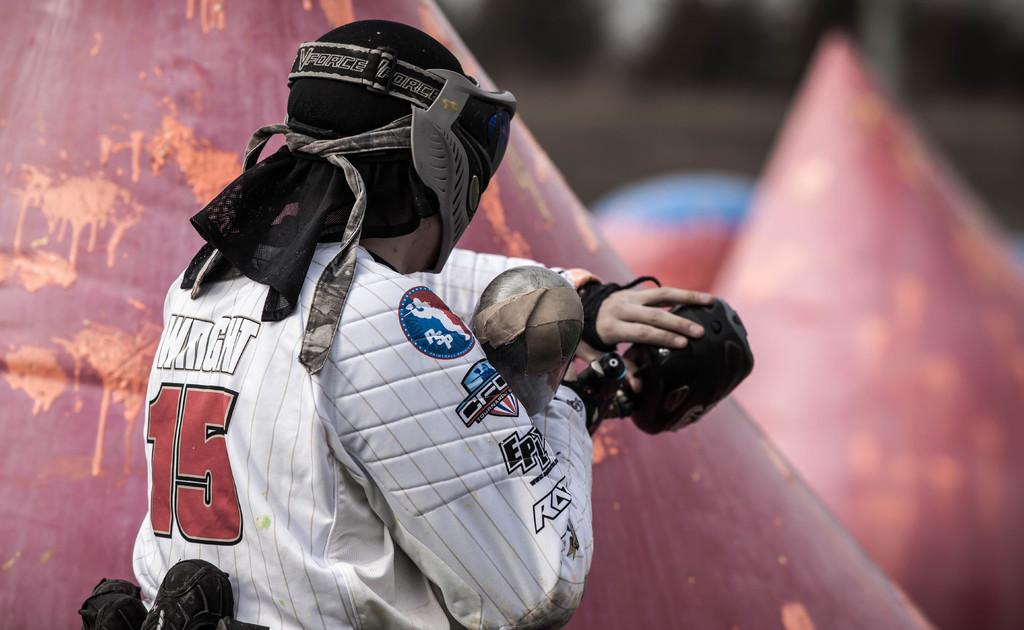Who is present in the image? There is a man in the image. What is the man wearing? The man is wearing a jacket and a helmet. What is the man holding in the image? The man is holding a camera. What can be seen in the background of the image? There are objects in the shape of a cone in the background. How would you describe the background of the image? The background is blurred. What type of copper material is present in the image? There is no copper material present in the image. 